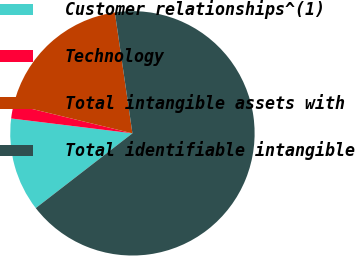Convert chart to OTSL. <chart><loc_0><loc_0><loc_500><loc_500><pie_chart><fcel>Customer relationships^(1)<fcel>Technology<fcel>Total intangible assets with<fcel>Total identifiable intangible<nl><fcel>12.42%<fcel>1.85%<fcel>18.91%<fcel>66.82%<nl></chart> 